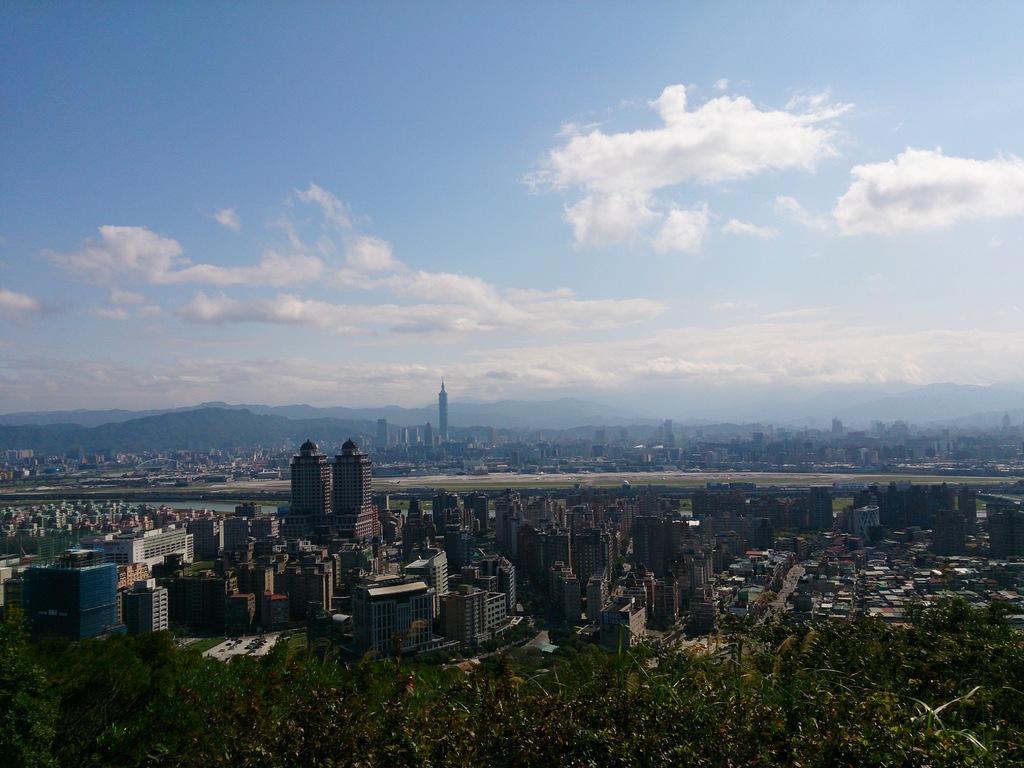Please provide a concise description of this image. In the picture I can see buildings, trees and some other things. In the background I can see mountains and the sky. 